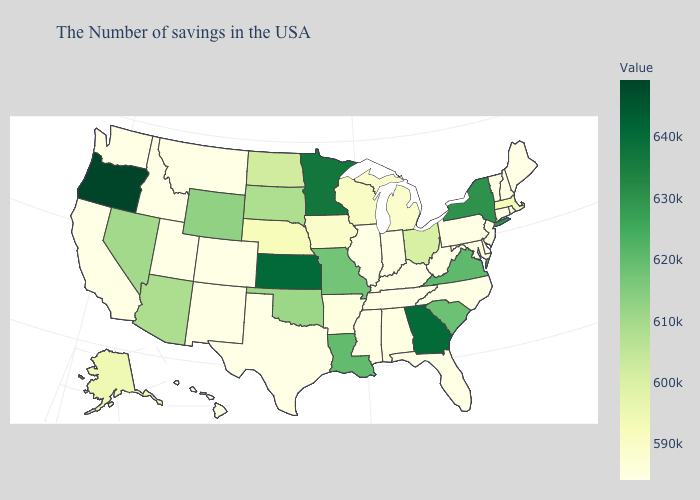Among the states that border Ohio , does Michigan have the lowest value?
Answer briefly. No. Among the states that border Nevada , does Oregon have the highest value?
Write a very short answer. Yes. Does South Carolina have the lowest value in the South?
Quick response, please. No. Among the states that border South Dakota , which have the highest value?
Quick response, please. Minnesota. 